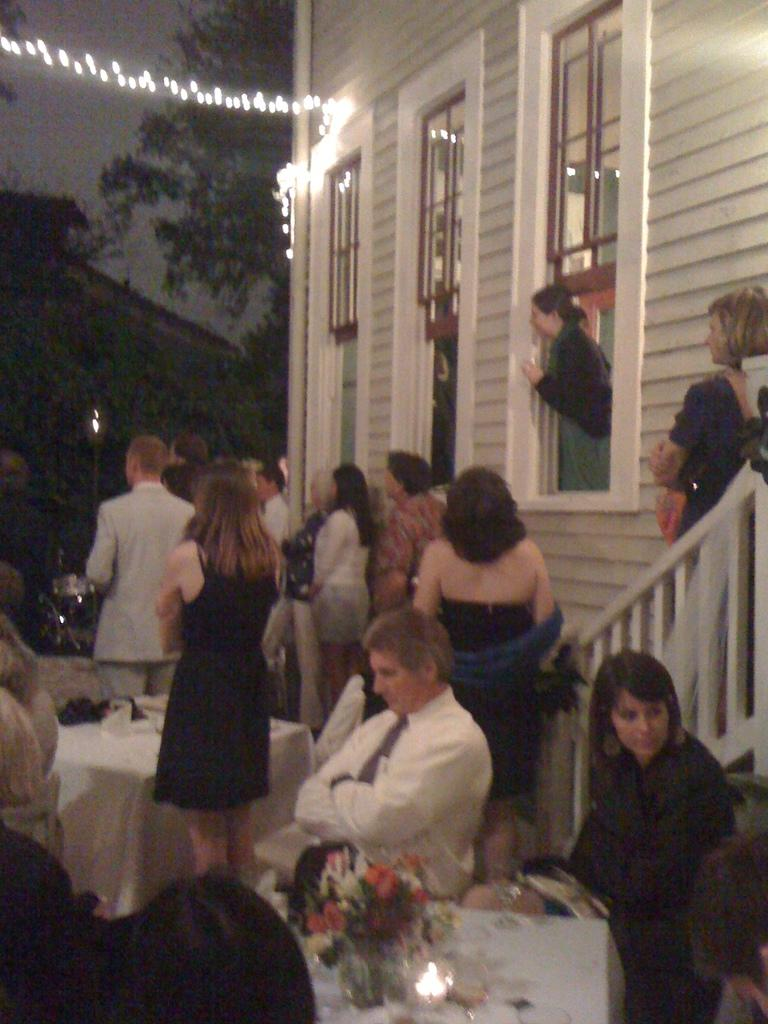What can be seen in the image that provides illumination? There are lights in the image that provide illumination. What part of the natural environment is visible in the image? The sky and trees are visible in the image. Are there any structures or objects in the image? Yes, there are windows, a wall, tables, and a candle present in the image. What are the people in the image doing? People are sitting on the right side of the image. What items can be seen on the right side of the image? Glasses, tables, flower bouquets, and a candle are visible on the right side of the image. What type of fuel is being used by the sea in the image? There is no sea present in the image, so the question about fuel is not applicable. What fictional character is sitting on the right side of the image? The image does not depict any fictional characters; it shows people sitting on the right side. 